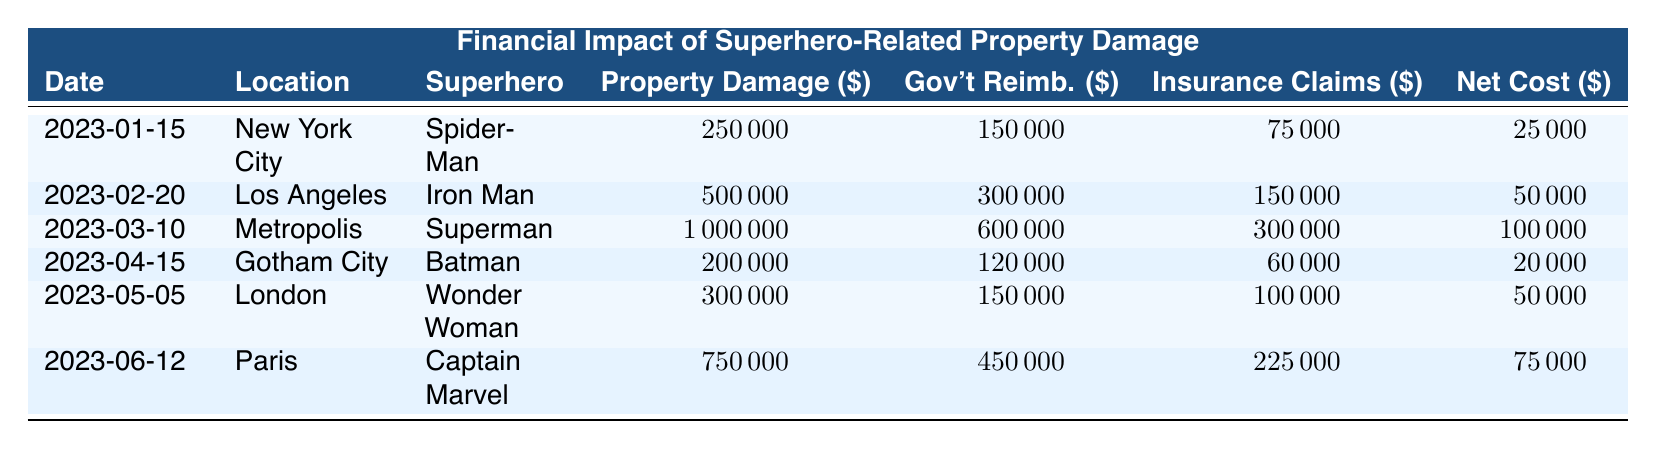What is the total property damage cost across all incidents? To find the total property damage cost, we need to sum the values from the "Property Damage" column: 250000 + 500000 + 1000000 + 200000 + 300000 + 750000 = 2500000.
Answer: 2500000 Which superhero caused the highest property damage cost? Looking at the "Property Damage" column, Superman's incident has the highest value at 1000000.
Answer: Superman What was the net cost to the city after the incident involving Iron Man? The net cost for Iron Man's incident is listed in the "Net Cost" column, showing a value of 50000.
Answer: 50000 Was there any incident where the net cost to the city was zero or negative? Reviewing the "Net Cost" column, all values are positive, hence there are no incidents with zero or negative net costs.
Answer: No What is the average amount of government reimbursements across all incidents? To calculate the average, we sum the reimbursements: 150000 + 300000 + 600000 + 120000 + 150000 + 450000 = 1875000; dividing that by the number of incidents (6) gives us 1875000 / 6 = 312500.
Answer: 312500 Which incident involved the least net cost to the city? By checking the "Net Cost" column, the lowest net cost is noted to be 20000 from Batman's incident.
Answer: Batman's incident If we consider only the incidents involving Spider-Man and Wonder Woman, what is the total insurance claims filed? We add the insurance claims for both superheroes: 75000 (Spider-Man) + 100000 (Wonder Woman) = 175000.
Answer: 175000 What incident occurred in Paris, and what was its property damage cost? The incident in Paris involved Captain Marvel, and the property damage cost is listed as 750000.
Answer: Captain Marvel, 750000 How much more did Superman's incident cost compared to Batman's incident? To find the difference, subtract Batman's property damage cost (200000) from Superman's (1000000): 1000000 - 200000 = 800000.
Answer: 800000 